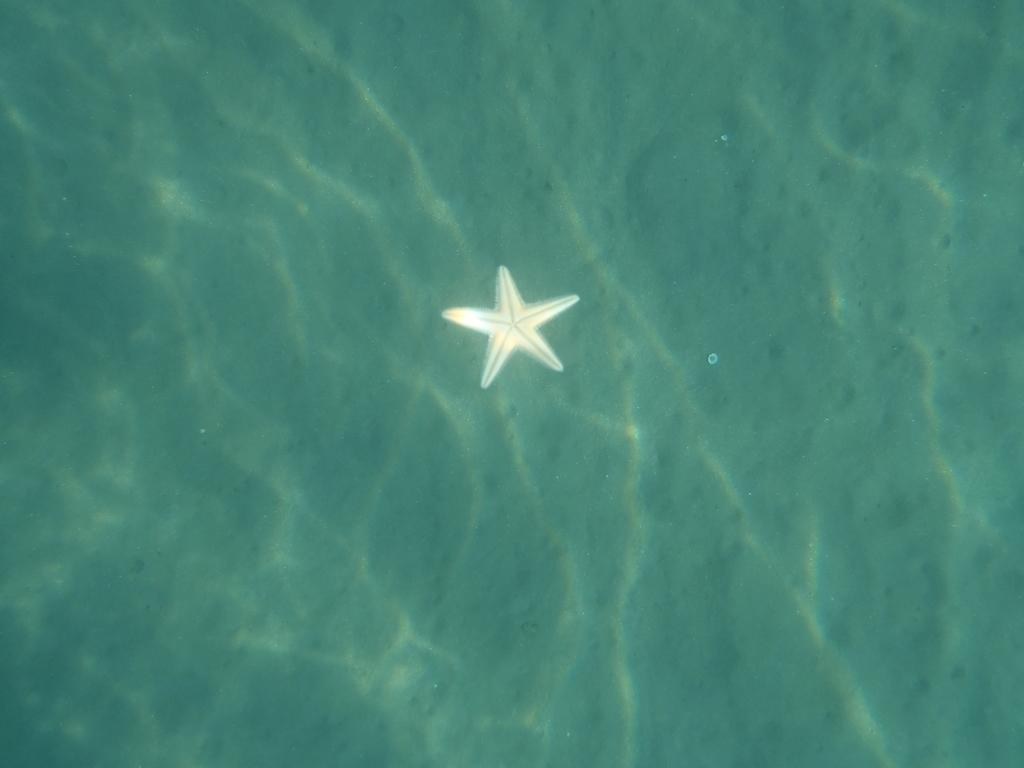What type of marine animal is in the image? There is a starfish in the image. What is the primary element surrounding the starfish? There is water visible in the image. What type of cake is being decorated with a wrench in the image? There is no cake or wrench present in the image; it features a starfish in water. 